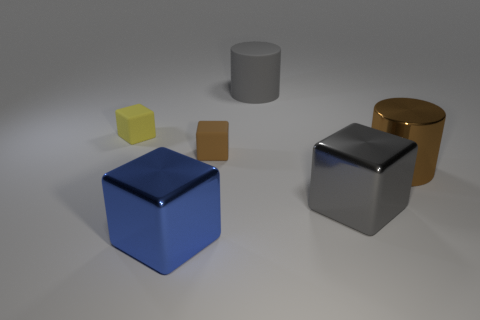Is there any other thing that is made of the same material as the small brown cube?
Give a very brief answer. Yes. There is a tiny block that is the same color as the big metallic cylinder; what is it made of?
Your response must be concise. Rubber. Does the gray shiny object have the same size as the matte object to the left of the small brown object?
Give a very brief answer. No. There is a large metal thing that is behind the gray object in front of the large brown cylinder; what color is it?
Your answer should be compact. Brown. What number of objects are large cylinders that are in front of the tiny yellow cube or large objects in front of the tiny yellow rubber cube?
Give a very brief answer. 3. Is the blue block the same size as the gray rubber cylinder?
Your answer should be very brief. Yes. There is a big object that is to the left of the small brown cube; does it have the same shape as the gray matte object on the left side of the shiny cylinder?
Ensure brevity in your answer.  No. The brown matte object is what size?
Offer a very short reply. Small. What is the material of the large cylinder that is in front of the large cylinder that is behind the small object that is to the right of the blue cube?
Offer a terse response. Metal. How many other objects are there of the same color as the shiny cylinder?
Ensure brevity in your answer.  1. 